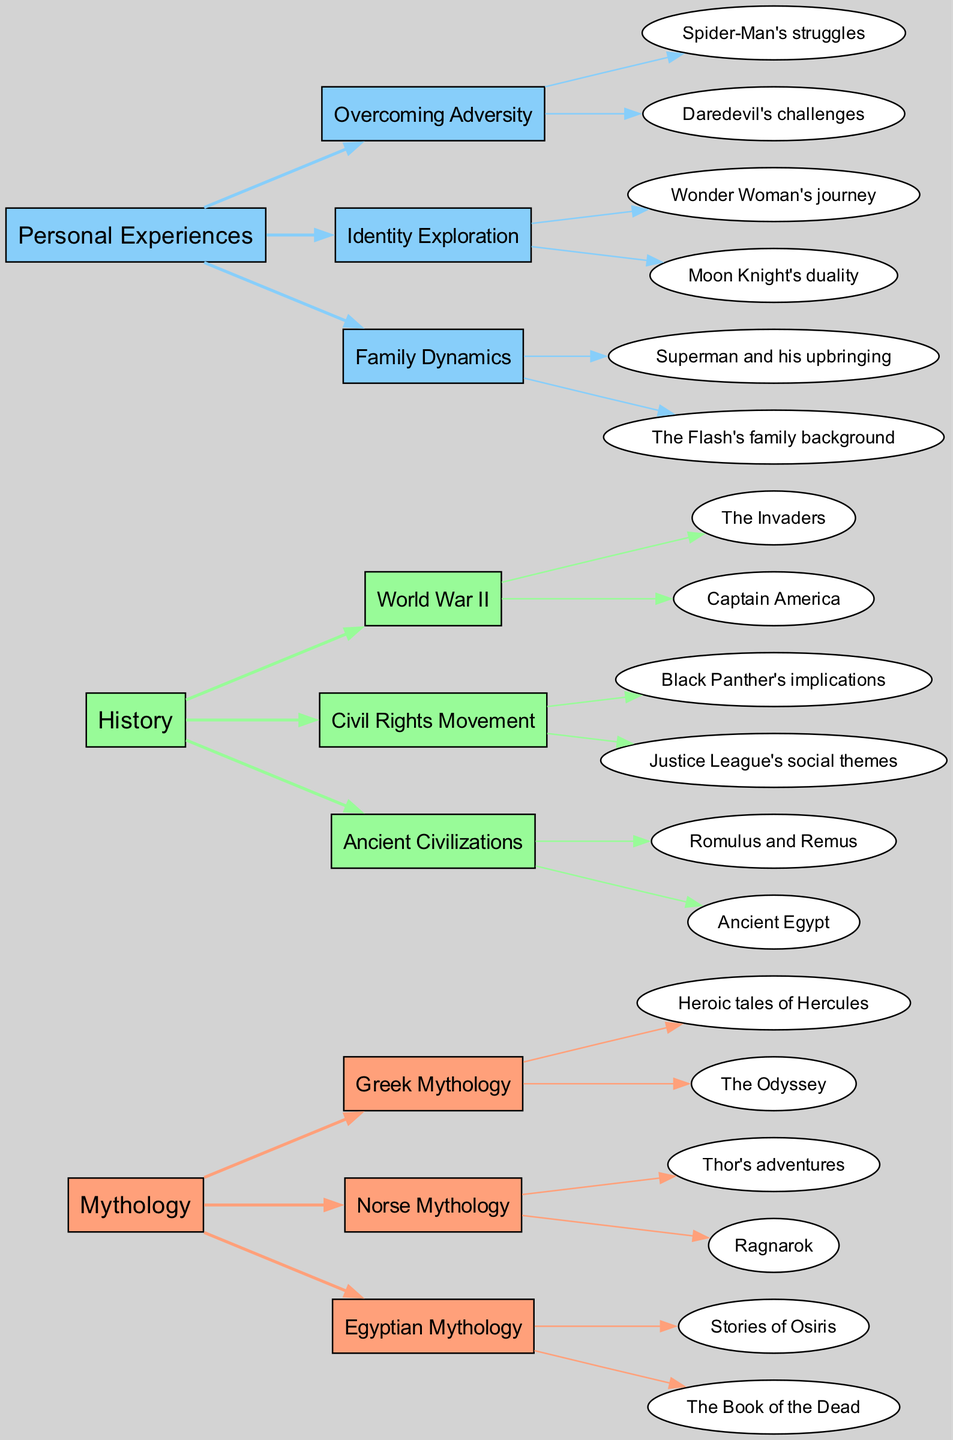What are the three main sources of inspiration for comic book storylines? The diagram identifies three primary sources: Mythology, History, and Personal Experiences. Each source is represented as a node at the left, indicating their significance in influencing comic book narratives.
Answer: Mythology, History, Personal Experiences How many unique connections are represented under the "History" source? Under the "History" source, there are three unique connections shown: World War II, Civil Rights Movement, and Ancient Civilizations. This is counted by examining the connections listed under the History node.
Answer: 3 Which mythology examples are related to Norse mythology? The examples linked to Norse mythology are "Thor's adventures" and "Ragnarok." This can be verified by tracing the connections and resulting examples directly under this mythology node.
Answer: Thor's adventures, Ragnarok What relationships exist between Personal Experiences and Identity Exploration? The relationship involves that Identity Exploration is one of the connections under the Personal Experiences source, with examples such as "Wonder Woman's journey" and "Moon Knight's duality." This is determined by analyzing the connections under the Personal Experiences source.
Answer: Wonder Woman's journey, Moon Knight's duality What is the single connection listed under the "Mythology" source that corresponds to Egyptian mythology? The connection that corresponds to Egyptian mythology is "Stories of Osiris" and "The Book of the Dead." This information is found by examining the connections listed under the Mythology source.
Answer: Stories of Osiris, The Book of the Dead Which source is connected to stories about the Civil Rights Movement? The source connected to the Civil Rights Movement is History, as this connection is clearly marked under the History node, leading to examples that reflect social themes. This relationship is identified by tracing the node connections.
Answer: History How many examples are provided under the connection "Overcoming Adversity"? There are two examples listed under the connection "Overcoming Adversity," specifically "Spider-Man's struggles" and "Daredevil's challenges." This is determined by counting the number of examples shown under that specific connection.
Answer: 2 